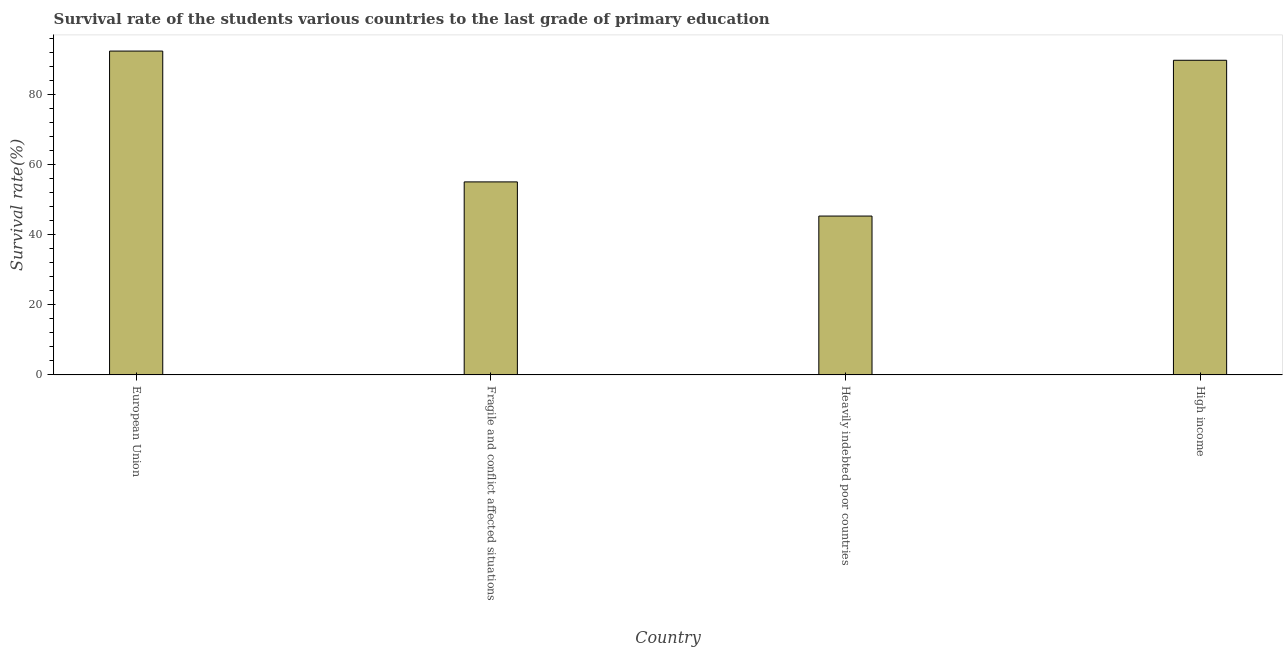Does the graph contain any zero values?
Give a very brief answer. No. Does the graph contain grids?
Provide a succinct answer. No. What is the title of the graph?
Provide a succinct answer. Survival rate of the students various countries to the last grade of primary education. What is the label or title of the Y-axis?
Your answer should be very brief. Survival rate(%). What is the survival rate in primary education in Heavily indebted poor countries?
Your answer should be very brief. 45.33. Across all countries, what is the maximum survival rate in primary education?
Ensure brevity in your answer.  92.41. Across all countries, what is the minimum survival rate in primary education?
Your answer should be compact. 45.33. In which country was the survival rate in primary education minimum?
Offer a terse response. Heavily indebted poor countries. What is the sum of the survival rate in primary education?
Provide a short and direct response. 282.61. What is the difference between the survival rate in primary education in European Union and High income?
Give a very brief answer. 2.63. What is the average survival rate in primary education per country?
Your answer should be very brief. 70.65. What is the median survival rate in primary education?
Provide a succinct answer. 72.43. What is the ratio of the survival rate in primary education in European Union to that in Heavily indebted poor countries?
Offer a terse response. 2.04. Is the survival rate in primary education in European Union less than that in Fragile and conflict affected situations?
Your answer should be very brief. No. What is the difference between the highest and the second highest survival rate in primary education?
Provide a short and direct response. 2.63. Is the sum of the survival rate in primary education in Heavily indebted poor countries and High income greater than the maximum survival rate in primary education across all countries?
Your answer should be very brief. Yes. What is the difference between the highest and the lowest survival rate in primary education?
Provide a succinct answer. 47.08. How many countries are there in the graph?
Ensure brevity in your answer.  4. What is the difference between two consecutive major ticks on the Y-axis?
Provide a succinct answer. 20. What is the Survival rate(%) of European Union?
Ensure brevity in your answer.  92.41. What is the Survival rate(%) in Fragile and conflict affected situations?
Your answer should be very brief. 55.08. What is the Survival rate(%) in Heavily indebted poor countries?
Offer a terse response. 45.33. What is the Survival rate(%) of High income?
Provide a succinct answer. 89.79. What is the difference between the Survival rate(%) in European Union and Fragile and conflict affected situations?
Offer a very short reply. 37.33. What is the difference between the Survival rate(%) in European Union and Heavily indebted poor countries?
Your answer should be very brief. 47.08. What is the difference between the Survival rate(%) in European Union and High income?
Make the answer very short. 2.63. What is the difference between the Survival rate(%) in Fragile and conflict affected situations and Heavily indebted poor countries?
Keep it short and to the point. 9.75. What is the difference between the Survival rate(%) in Fragile and conflict affected situations and High income?
Your response must be concise. -34.7. What is the difference between the Survival rate(%) in Heavily indebted poor countries and High income?
Provide a short and direct response. -44.45. What is the ratio of the Survival rate(%) in European Union to that in Fragile and conflict affected situations?
Offer a very short reply. 1.68. What is the ratio of the Survival rate(%) in European Union to that in Heavily indebted poor countries?
Keep it short and to the point. 2.04. What is the ratio of the Survival rate(%) in European Union to that in High income?
Provide a short and direct response. 1.03. What is the ratio of the Survival rate(%) in Fragile and conflict affected situations to that in Heavily indebted poor countries?
Your answer should be very brief. 1.22. What is the ratio of the Survival rate(%) in Fragile and conflict affected situations to that in High income?
Make the answer very short. 0.61. What is the ratio of the Survival rate(%) in Heavily indebted poor countries to that in High income?
Your answer should be very brief. 0.51. 